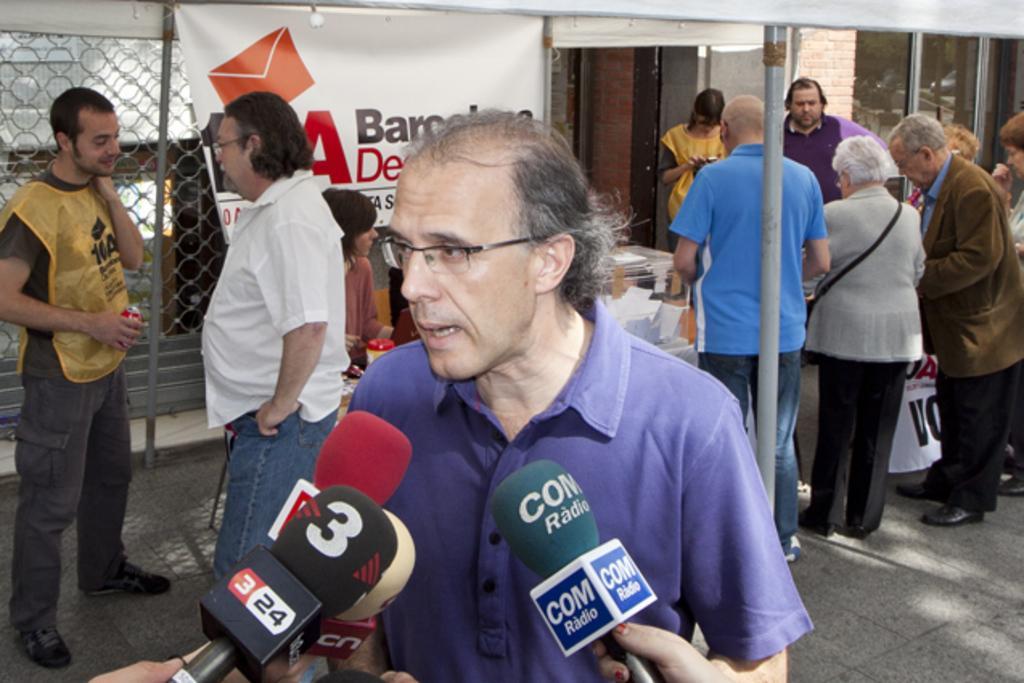Could you give a brief overview of what you see in this image? In this picture there are people and we can see microphones, tent, banners, poles and objects. In the background of the image we can see mesh, wall and glass. 